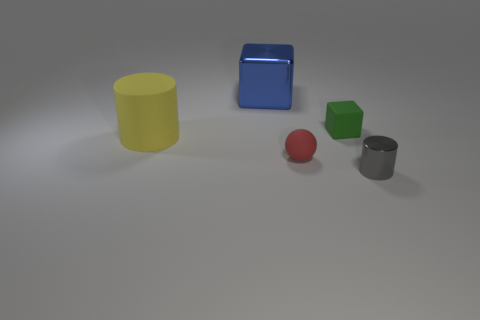There is a cube that is left of the block that is on the right side of the red rubber object; what is its color?
Your answer should be very brief. Blue. Is there a green thing that has the same material as the yellow thing?
Keep it short and to the point. Yes. What is the material of the cube right of the large thing behind the green block?
Your response must be concise. Rubber. What number of big shiny objects have the same shape as the tiny gray metal object?
Your answer should be very brief. 0. The blue object is what shape?
Offer a very short reply. Cube. Is the number of small red rubber balls less than the number of tiny purple metal cubes?
Give a very brief answer. No. What material is the gray thing that is the same shape as the yellow thing?
Your response must be concise. Metal. Are there more rubber cylinders than cubes?
Your answer should be very brief. No. What number of other things are the same color as the rubber cylinder?
Your response must be concise. 0. Is the material of the small cube the same as the blue block to the left of the tiny red sphere?
Your response must be concise. No. 